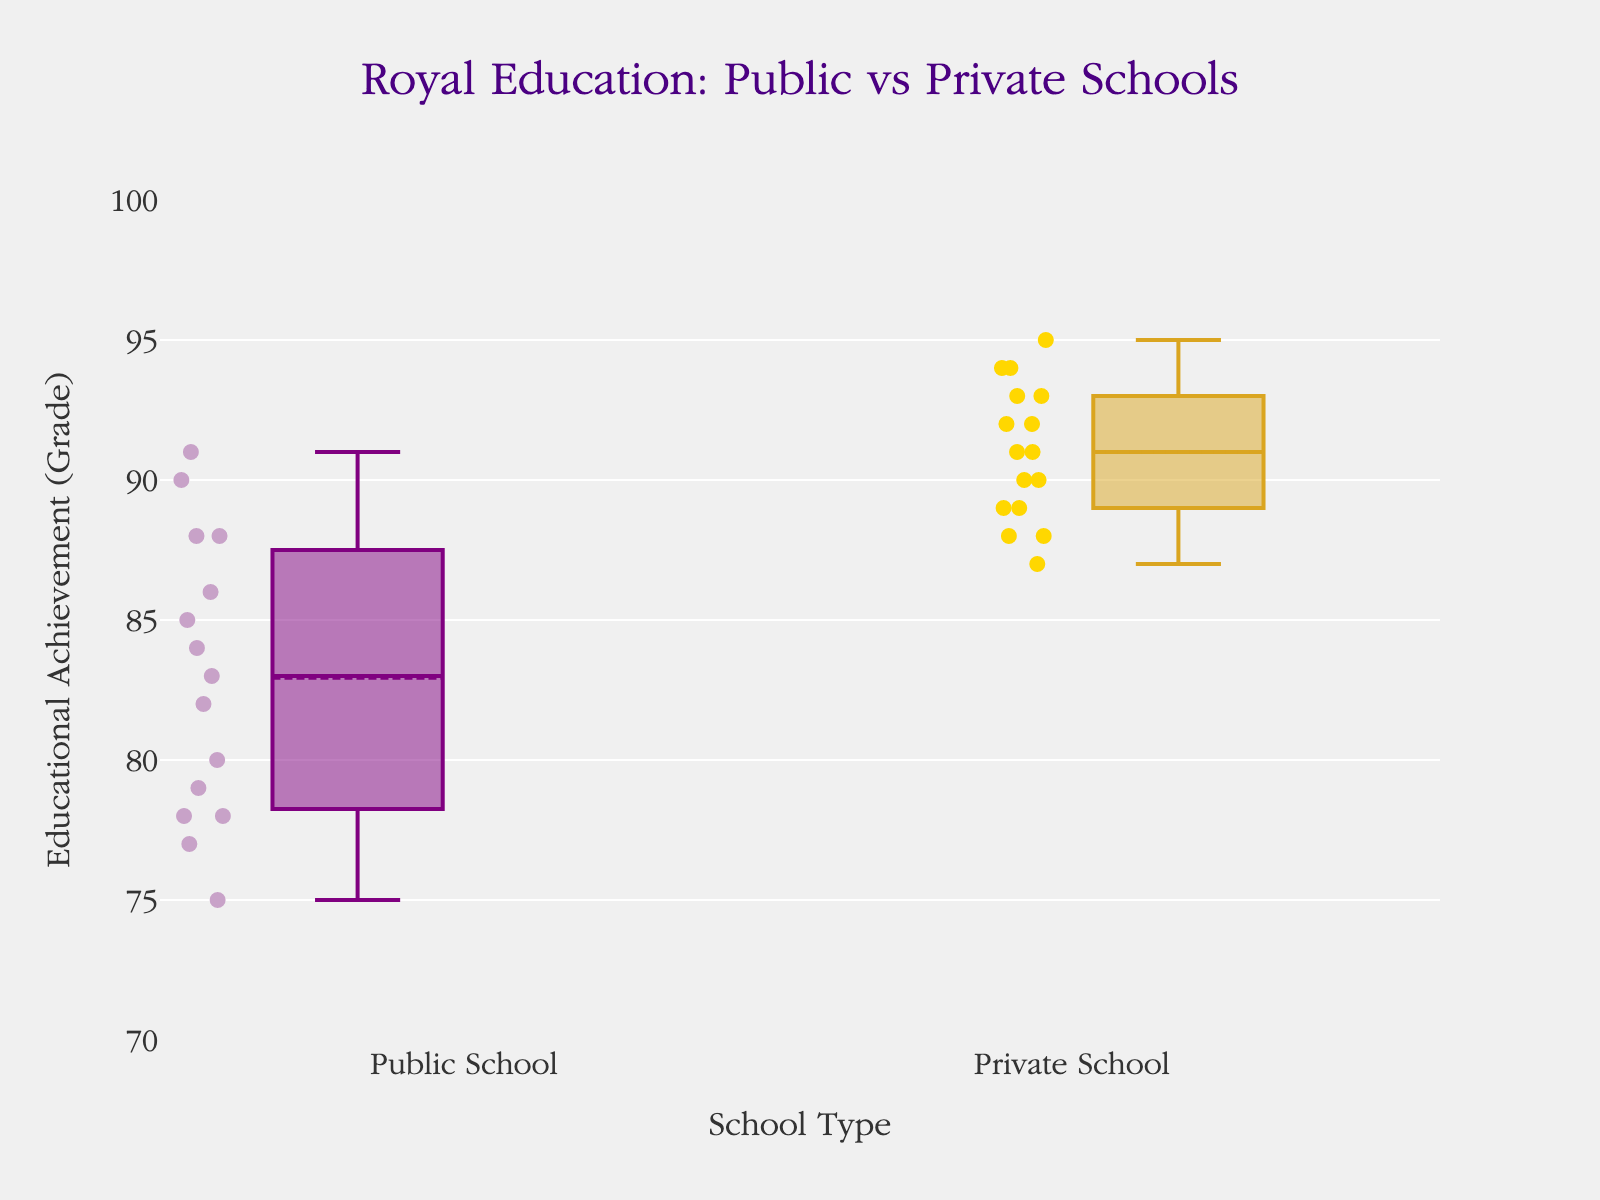what is the title of the plot? The title of the plot is written at the top and provides context for what the figure is about.
Answer: Royal Education: Public vs Private Schools what does the y-axis represent? The y-axis is labeled on the left side and shows the metric being measured.
Answer: Educational Achievement (Grade) which school type has the wider box in terms of educational achievements? The width of the box indicates the spread of data around the median; comparing both boxes can help determine which one has a wider range of values.
Answer: Public School what is the median grade for public schools? The median is represented by the line inside the box. Visual inspection can give the approximate median value.
Answer: Around 82 which school type has higher overall grades? Observing the positions of the boxes vertically shows which set of grades tends to be higher overall.
Answer: Private School how do the average grades of public and private schools compare? The average or mean is often depicted by a special marker (e.g., a dot or line) on the box plot. Comparing their positions can give an indication of how the averages differ.
Answer: Private schools have a higher average grade what is the interquartile range (IQR) for private schools? The IQR is the range between the 1st quartile (25th percentile) and the 3rd quartile (75th percentile) and can be identified by the vertical spans of the boxes.
Answer: About 4 (from 89 to 93) which group has the lower minimum grade? The minimum value can be found by looking at the bottom whisker of each boxplot.
Answer: Public School how many students' grades are shown for public schools? Each data point is represented by a marker in the box plot. Counting the markers under “Public School” will give the total number of students.
Answer: 15 what is the range of the grades for public schools? The range is the difference between the highest and lowest values, as indicated by the top and bottom whiskers of the boxplot.
Answer: 75 to 91 